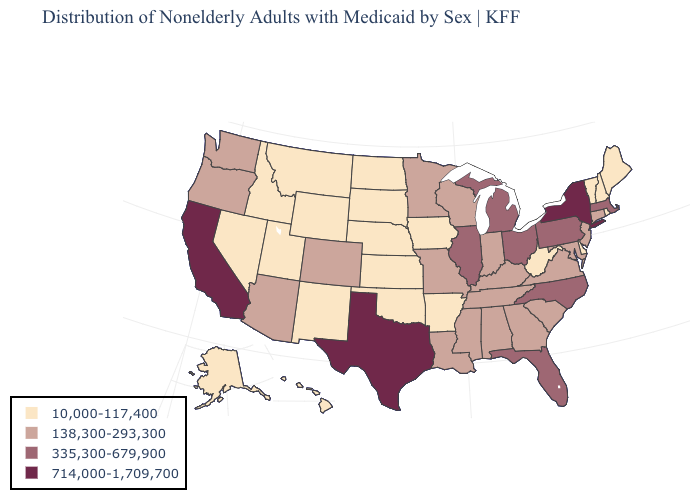Does the map have missing data?
Short answer required. No. What is the value of Indiana?
Give a very brief answer. 138,300-293,300. Does Texas have the highest value in the USA?
Write a very short answer. Yes. What is the highest value in the West ?
Answer briefly. 714,000-1,709,700. Which states have the lowest value in the USA?
Concise answer only. Alaska, Arkansas, Delaware, Hawaii, Idaho, Iowa, Kansas, Maine, Montana, Nebraska, Nevada, New Hampshire, New Mexico, North Dakota, Oklahoma, Rhode Island, South Dakota, Utah, Vermont, West Virginia, Wyoming. Name the states that have a value in the range 714,000-1,709,700?
Keep it brief. California, New York, Texas. Name the states that have a value in the range 138,300-293,300?
Keep it brief. Alabama, Arizona, Colorado, Connecticut, Georgia, Indiana, Kentucky, Louisiana, Maryland, Minnesota, Mississippi, Missouri, New Jersey, Oregon, South Carolina, Tennessee, Virginia, Washington, Wisconsin. Which states have the highest value in the USA?
Keep it brief. California, New York, Texas. Name the states that have a value in the range 335,300-679,900?
Keep it brief. Florida, Illinois, Massachusetts, Michigan, North Carolina, Ohio, Pennsylvania. Does the map have missing data?
Quick response, please. No. What is the value of Kentucky?
Write a very short answer. 138,300-293,300. Does Connecticut have the highest value in the USA?
Concise answer only. No. Is the legend a continuous bar?
Quick response, please. No. What is the value of South Dakota?
Quick response, please. 10,000-117,400. What is the value of New Jersey?
Quick response, please. 138,300-293,300. 